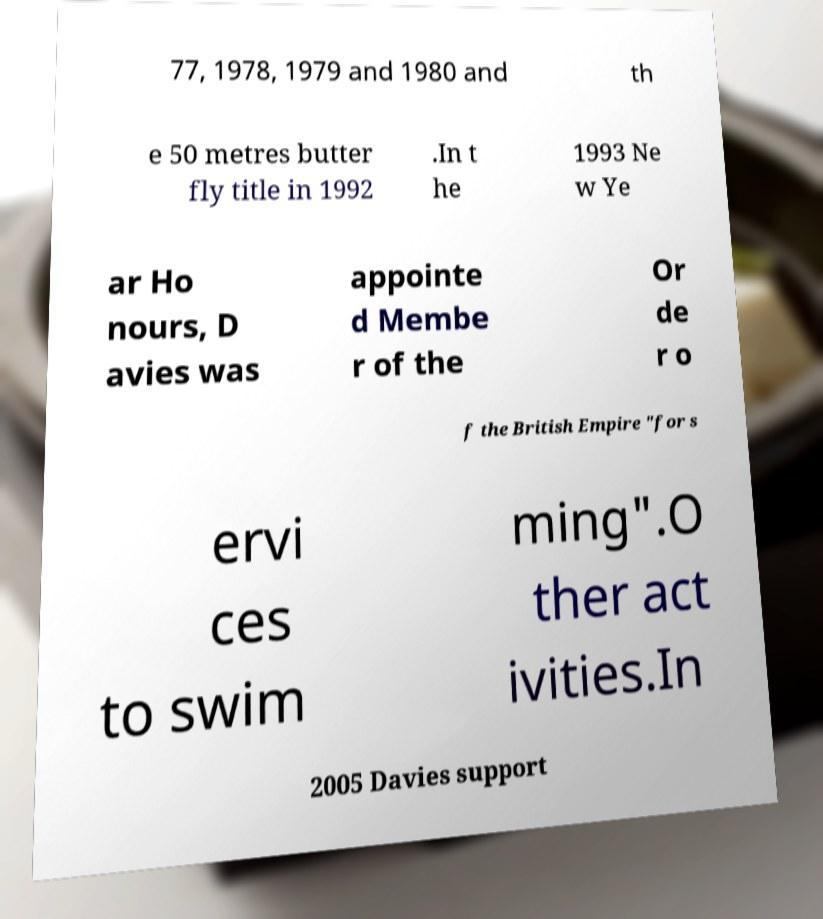Please read and relay the text visible in this image. What does it say? 77, 1978, 1979 and 1980 and th e 50 metres butter fly title in 1992 .In t he 1993 Ne w Ye ar Ho nours, D avies was appointe d Membe r of the Or de r o f the British Empire "for s ervi ces to swim ming".O ther act ivities.In 2005 Davies support 